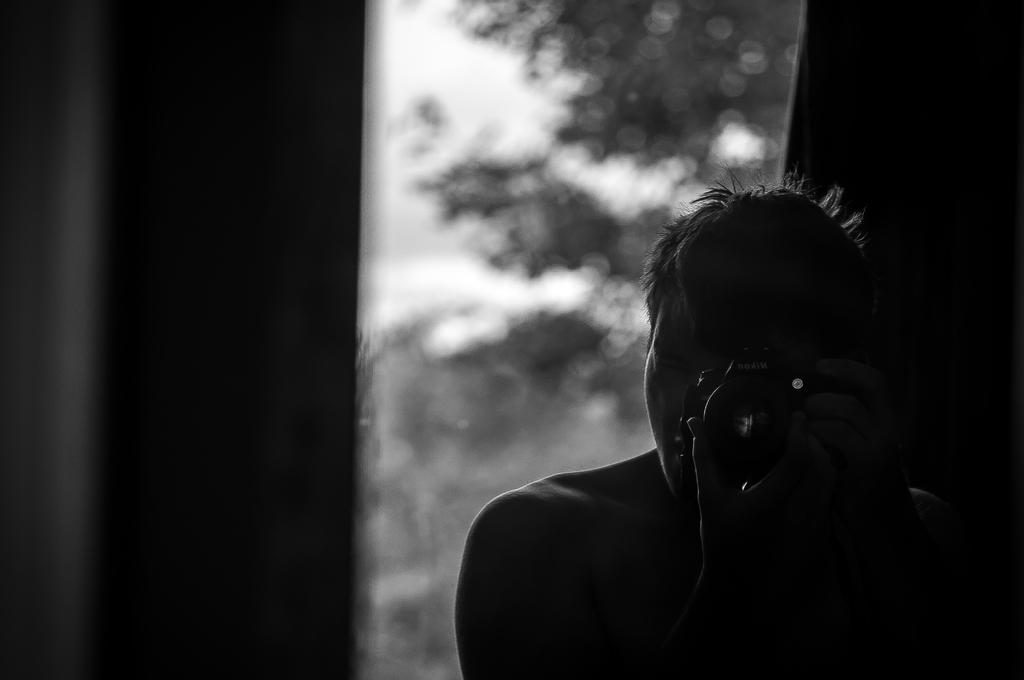What is the color scheme of the image? The image is black and white. What type of natural elements can be seen in the picture? There are trees in the picture. What part of the sky is visible in the image? There is sky visible in the picture. What type of man-made structures are present in the image? There are walls in the picture. What is the person in the image doing? There is a person holding a camera in the picture. How many geese are flying in the image? There are no geese present in the image. What type of wound can be seen on the person holding the camera? There is no wound visible on the person holding the camera in the image. 